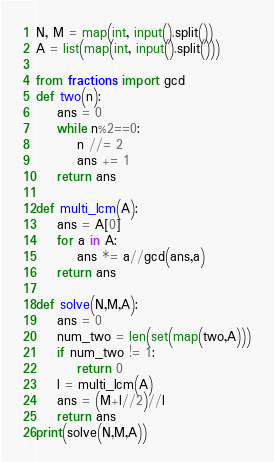Convert code to text. <code><loc_0><loc_0><loc_500><loc_500><_Cython_>N, M = map(int, input().split())
A = list(map(int, input().split()))

from fractions import gcd
def two(n):
    ans = 0
    while n%2==0:
        n //= 2
        ans += 1
    return ans

def multi_lcm(A):
    ans = A[0]
    for a in A:
        ans *= a//gcd(ans,a)
    return ans

def solve(N,M,A):
    ans = 0
    num_two = len(set(map(two,A)))
    if num_two != 1:
        return 0
    l = multi_lcm(A)
    ans = (M+l//2)//l
    return ans
print(solve(N,M,A))
</code> 